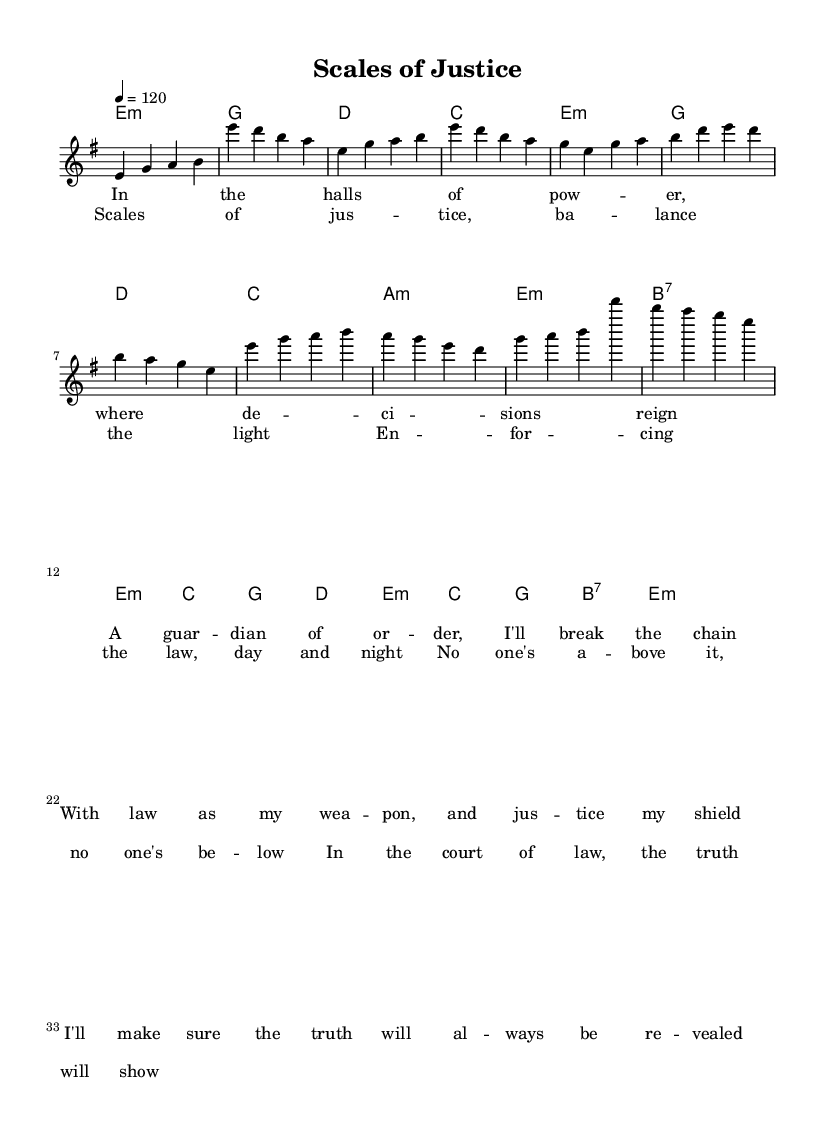What is the key signature of this music? The key signature is E minor, which has one sharp (F#). This is indicated at the beginning of the staff.
Answer: E minor What is the time signature of the piece? The time signature is 4/4, as indicated at the beginning of the score. This means there are four beats per measure, with the quarter note receiving one beat.
Answer: 4/4 What is the tempo marking for this piece? The tempo marking is 120 beats per minute, shown at the top of the score as "4 = 120". This indicates how fast the piece should be played.
Answer: 120 How many measures are in the chorus section? The chorus consists of 8 measures, as seen in the notation provided. Each line of the chorus has four measures, and there are two lines.
Answer: 8 What is the last chord in the chorus section? The last chord in the chorus is E minor, indicated in the harmony section at the end of the last measure of the chorus.
Answer: E minor What is the lyric theme of the verse? The theme of the verse revolves around justice and law, highlighting the guardian's role in making decisions and revealing the truth. This thematic focus can be inferred from the lyrics provided.
Answer: Justice How many notes are in the first measure of the melody? The first measure contains 4 notes (E, G, A, B), as shown in the melody line. Each of these notes is represented in the measure with a quarter note value.
Answer: 4 